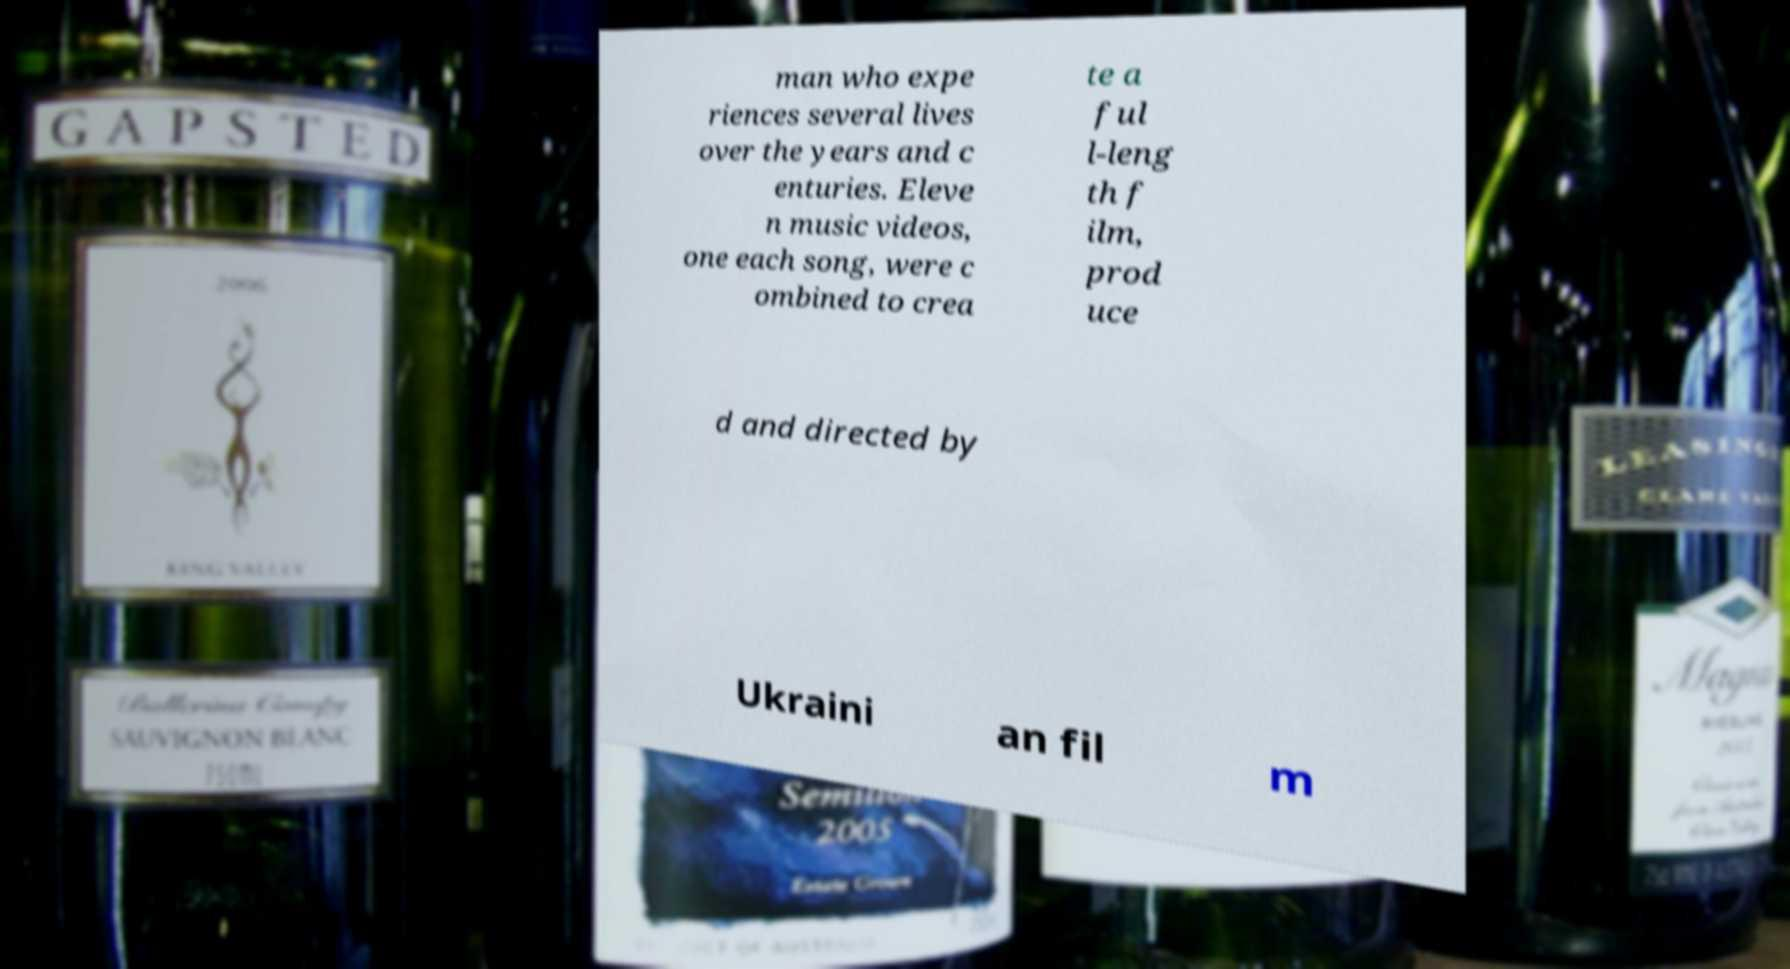Please identify and transcribe the text found in this image. man who expe riences several lives over the years and c enturies. Eleve n music videos, one each song, were c ombined to crea te a ful l-leng th f ilm, prod uce d and directed by Ukraini an fil m 